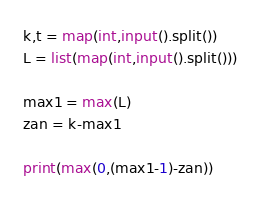<code> <loc_0><loc_0><loc_500><loc_500><_Python_>k,t = map(int,input().split())
L = list(map(int,input().split()))

max1 = max(L)
zan = k-max1

print(max(0,(max1-1)-zan))</code> 